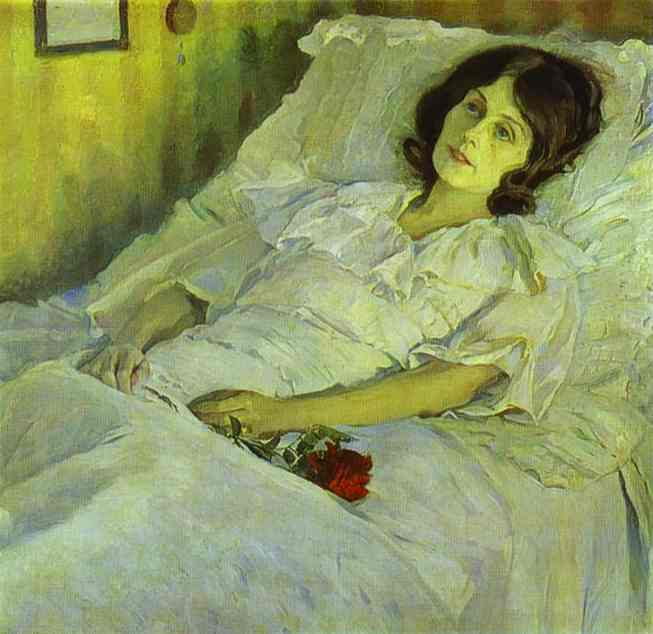What emotions do you think the artist intended to convey through the woman's expression and the overall mood of the painting? The artist seems to convey a complex mix of tranquility and melancholy. The woman's gaze is introspective, possibly reflecting on past events or personal feelings. The subdued lighting and soft colors enhance the mood of contemplation and quietude, possibly suggesting a moment of solitude or reflection on personal matters. 